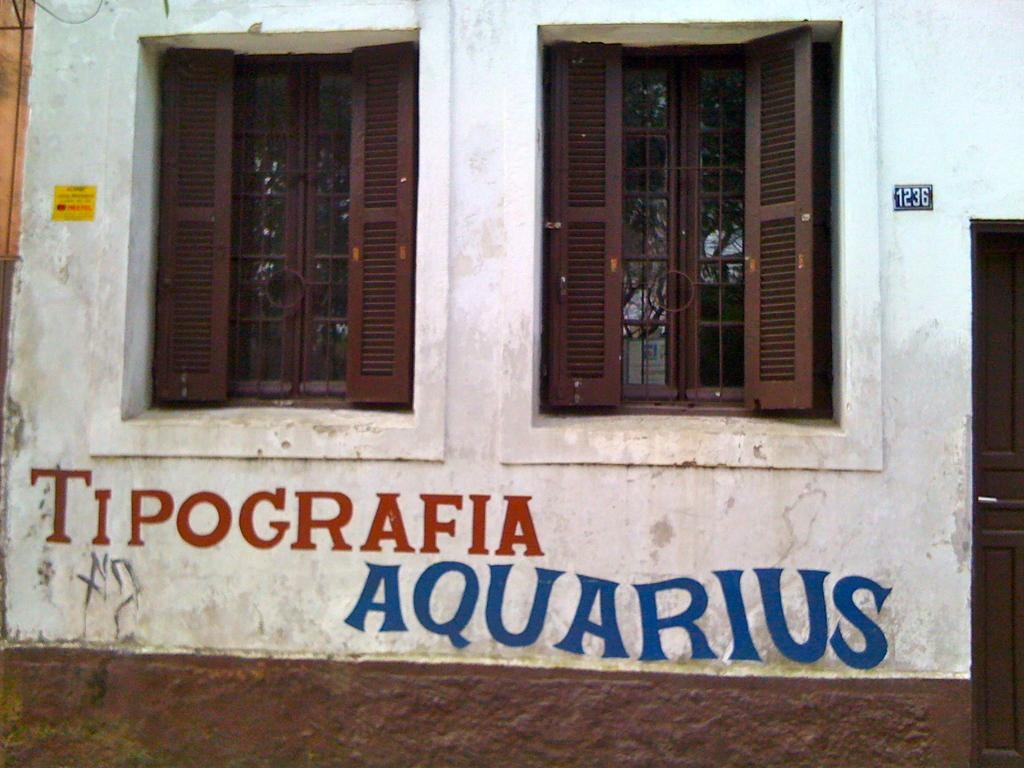What type of structure is visible in the image? There is a building present in the image. What can be seen on the building? There is text on the building. What architectural features are present on the building? There are windows and a door on the building. What can be seen through the windows? Trees are visible through the windows. How many cats are sitting on the trousers in the image? There are no cats or trousers present in the image. What type of cow can be seen grazing near the building? There is no cow present in the image; it only features a building with text, windows, and a door. 